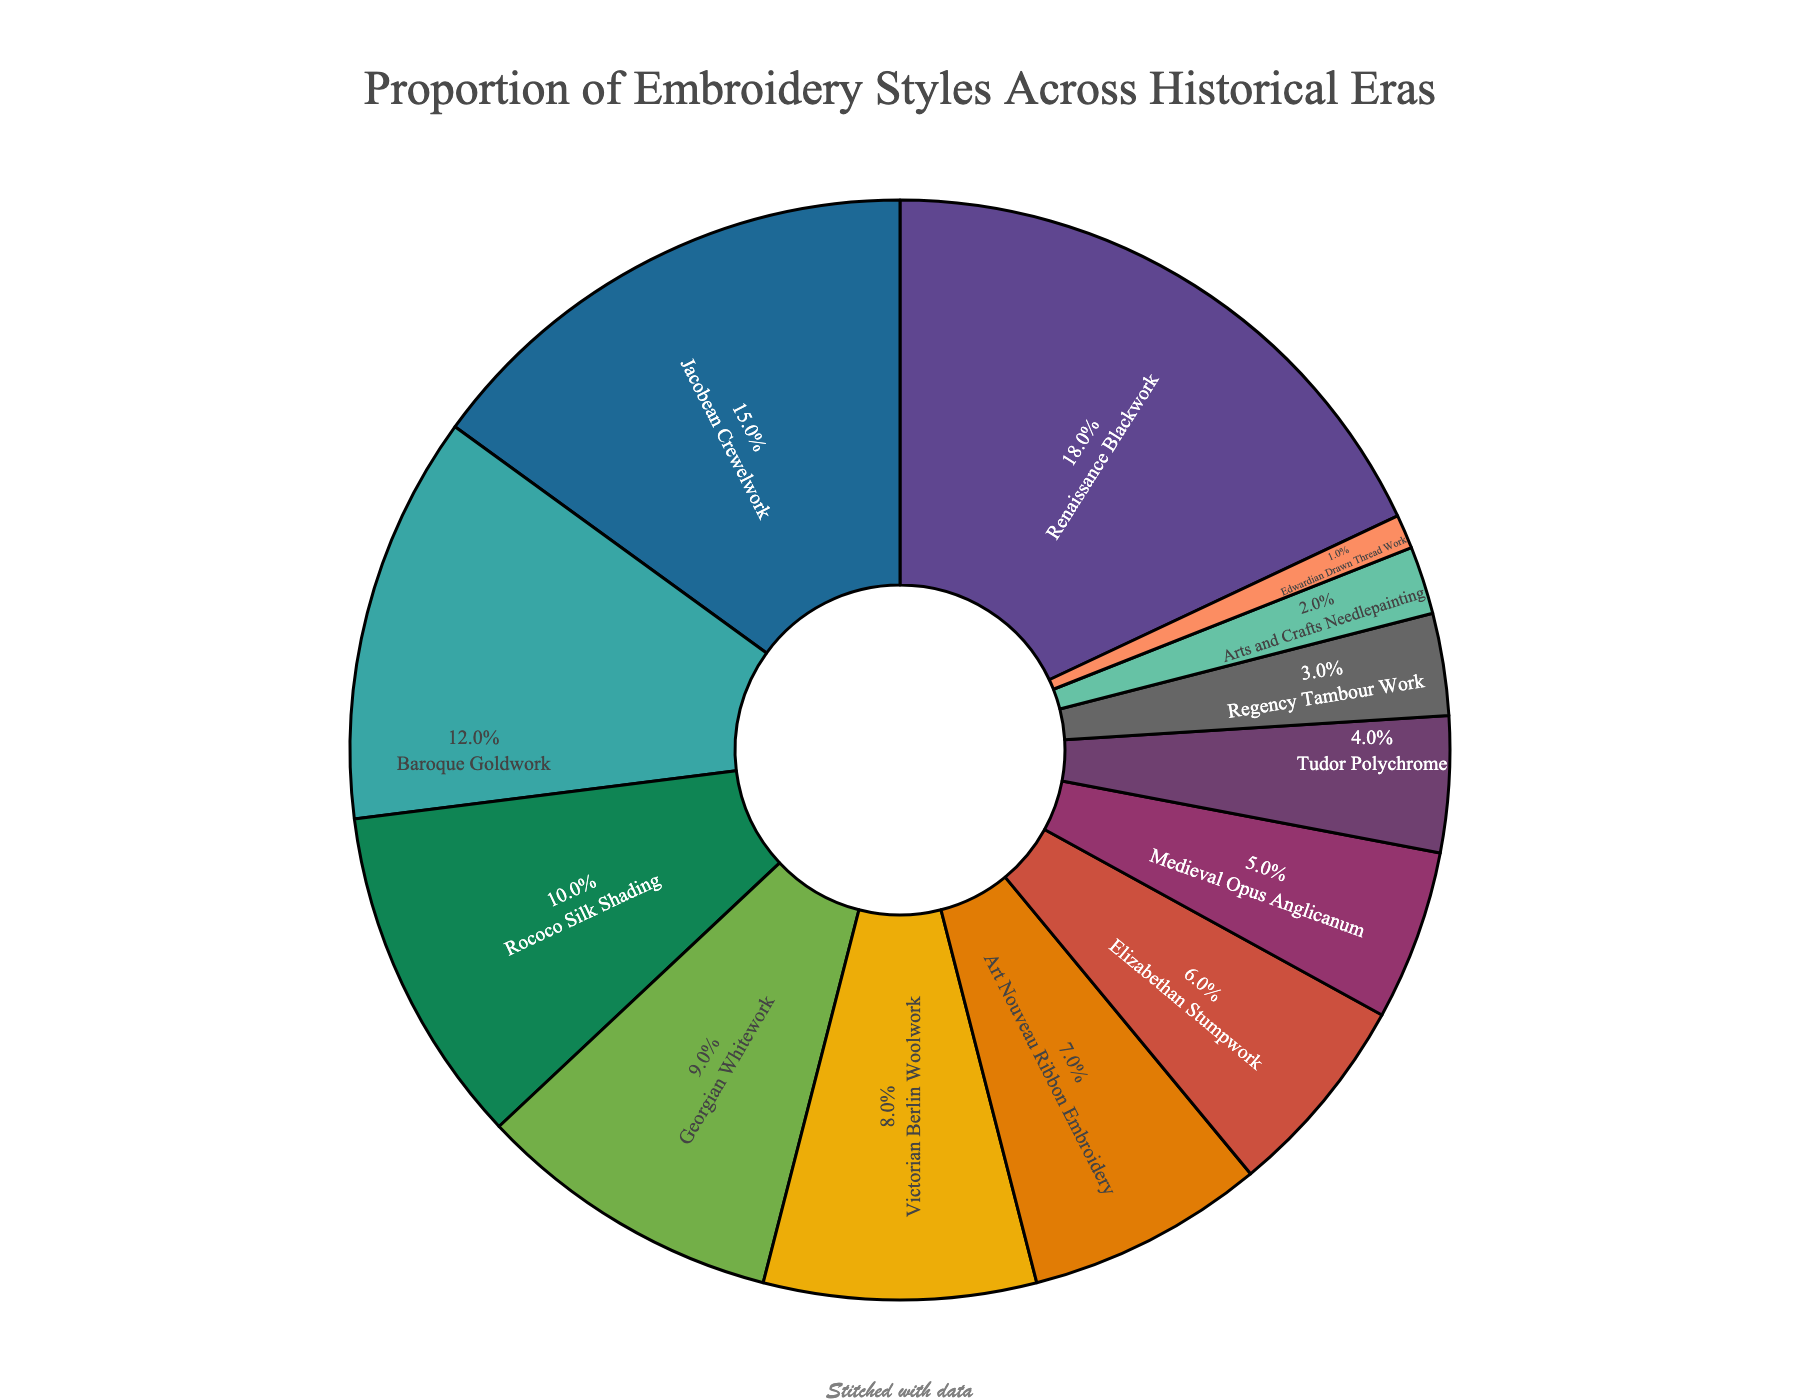What is the most prevalent embroidery style shown in the chart? The most prevalent embroidery style can be identified by looking for the segment with the largest percentage. In this case, it is Renaissance Blackwork with 18%.
Answer: Renaissance Blackwork Which historical era is represented by the smallest proportion and what is its percentage? To identify the smallest proportion, look for the smallest slice in the pie chart. Edwardian Drawn Thread Work has the smallest percentage, which is 1%.
Answer: Edwardian Drawn Thread Work, 1% Do Jacobean Crewelwork and Baroque Goldwork together constitute more or less than 30% of the total? Add the percentages of Jacobean Crewelwork (15%) and Baroque Goldwork (12%) to see if they total more or less than 30%. The combined percentage is 15% + 12% = 27%, which is less than 30%.
Answer: Less How much more prevalent is Renaissance Blackwork compared to Arts and Crafts Needlepainting? Subtract the percentage of Arts and Crafts Needlepainting (2%) from the percentage of Renaissance Blackwork (18%) to find the difference. The difference is 18% - 2% = 16%.
Answer: 16% Rank the top three embroidery styles by percentage. To find the top three styles, rank the segments by their percentages. The top three are: (1) Renaissance Blackwork (18%), (2) Jacobean Crewelwork (15%), (3) Baroque Goldwork (12%).
Answer: Renaissance Blackwork, Jacobean Crewelwork, Baroque Goldwork Are Georgian Whitework and Victorian Berlin Woolwork together more prevalent than Rococo Silk Shading? Add the percentages of Georgian Whitework (9%) and Victorian Berlin Woolwork (8%), and compare the sum to Rococo Silk Shading (10%). The total for Georgian Whitework and Victorian Berlin Woolwork is 9% + 8% = 17%, which is more than 10%.
Answer: More Which embroidery style from before the Renaissance era has a higher percentage: Medieval Opus Anglicanum or Tudor Polychrome? Compare the percentages of Medieval Opus Anglicanum (5%) and Tudor Polychrome (4%). Medieval Opus Anglicanum has a higher percentage.
Answer: Medieval Opus Anglicanum What proportion of the embroidery styles are from before the 17th century (including Renaissance)? Sum the percentages of Renaissance Blackwork (18%), Elizabethan Stumpwork (6%), Medieval Opus Anglicanum (5%), and Tudor Polychrome (4%) to find the proportion from before the 17th century. The total is 18% + 6% + 5% + 4% = 33%.
Answer: 33% Compare the prevalence of Embroidery styles from the 18th century (Georgian, Regency) to the 19th century (Victorian, Arts and Crafts). Sum the percentages for the 18th century - Georgian Whitework (9%) and Regency Tambour Work (3%) - and compare with the 19th century - Victorian Berlin Woolwork (8%) and Arts and Crafts Needlepainting (2%). The 18th century total is 9% + 3% = 12% and the 19th century total is 8% + 2% = 10%.
Answer: The 18th century Are all the embroidery styles depicted in the pie chart? Check the data and see if all 13 embroidery styles are represented in the pie chart. Yes, all styles are depicted with their respective percentages in the pie chart.
Answer: Yes 